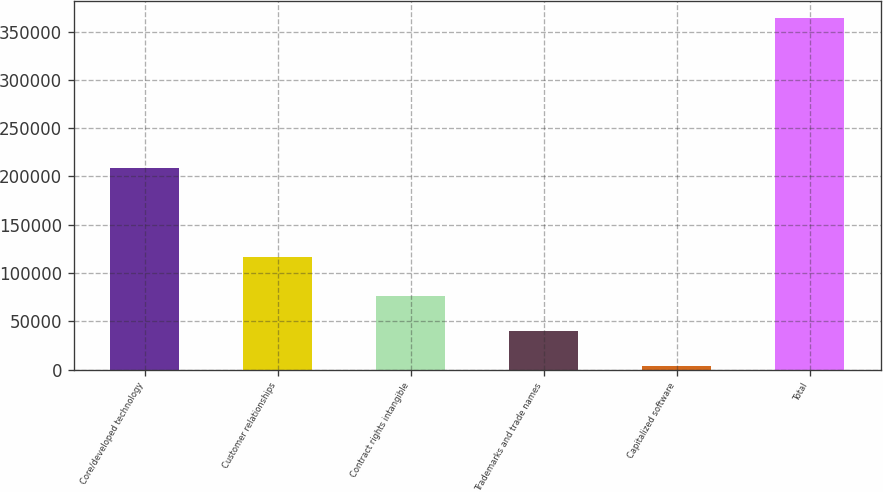Convert chart to OTSL. <chart><loc_0><loc_0><loc_500><loc_500><bar_chart><fcel>Core/developed technology<fcel>Customer relationships<fcel>Contract rights intangible<fcel>Trademarks and trade names<fcel>Capitalized software<fcel>Total<nl><fcel>208898<fcel>116738<fcel>76011<fcel>40055<fcel>4099<fcel>363659<nl></chart> 